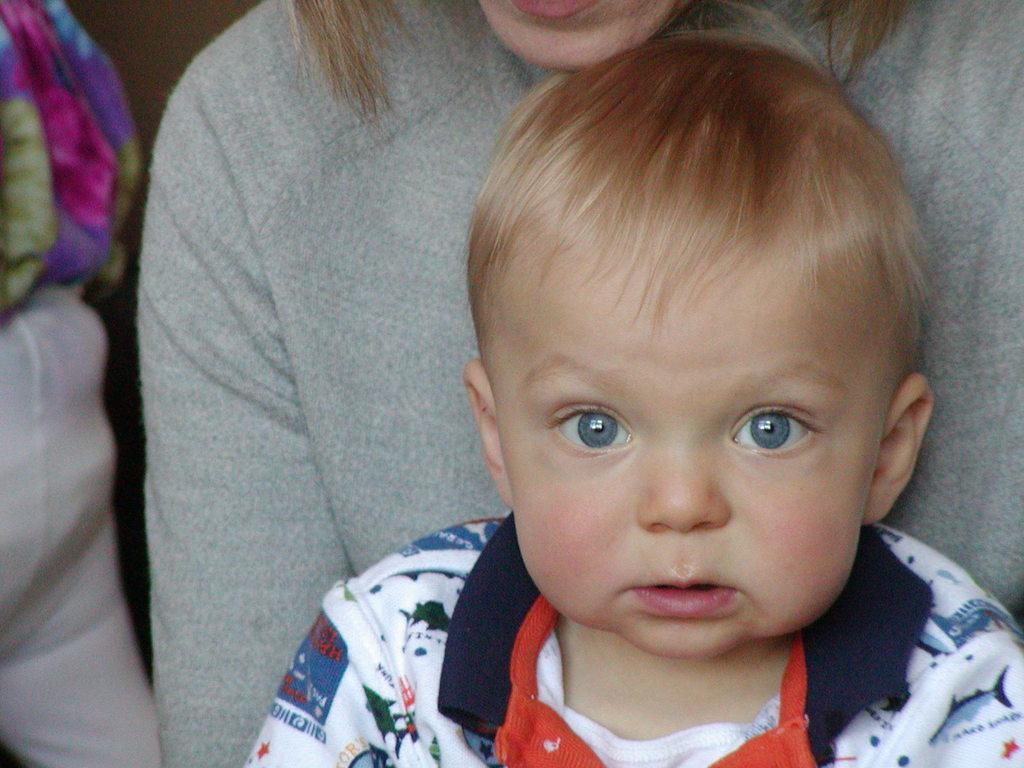Who or what is present in the image? There are people in the image. What else can be seen in the image besides the people? There are clothes in the image. What is the price of the spade in the image? There is no spade present in the image, so it is not possible to determine its price. 